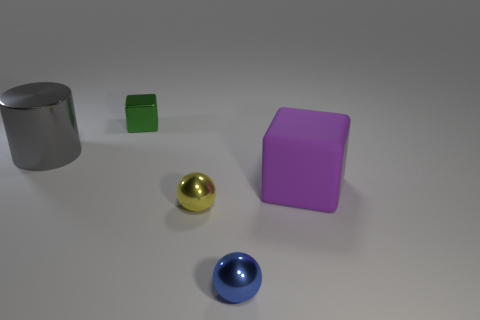Add 4 tiny purple spheres. How many objects exist? 9 Subtract all small metallic blocks. Subtract all large purple rubber things. How many objects are left? 3 Add 2 purple objects. How many purple objects are left? 3 Add 1 large purple rubber things. How many large purple rubber things exist? 2 Subtract 0 green balls. How many objects are left? 5 Subtract all blocks. How many objects are left? 3 